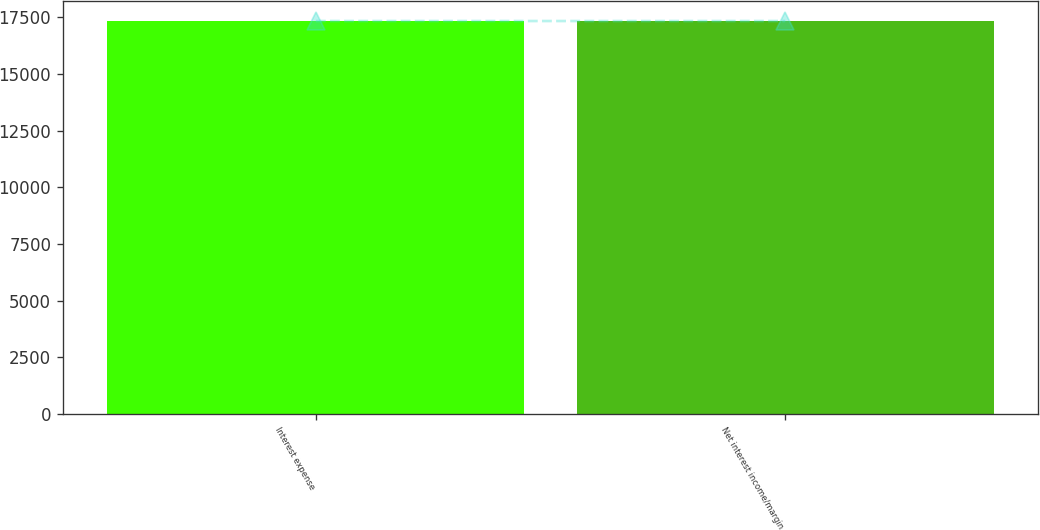Convert chart to OTSL. <chart><loc_0><loc_0><loc_500><loc_500><bar_chart><fcel>Interest expense<fcel>Net interest income/margin<nl><fcel>17327<fcel>17327.1<nl></chart> 